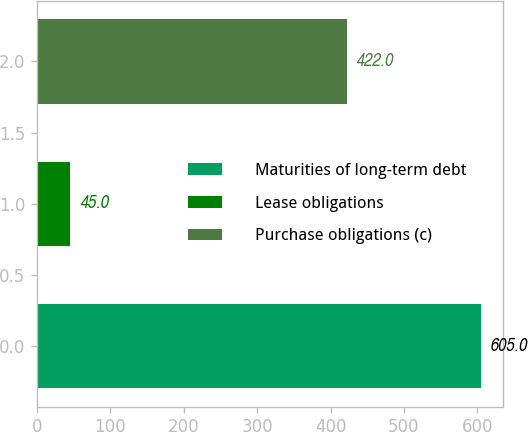Convert chart to OTSL. <chart><loc_0><loc_0><loc_500><loc_500><bar_chart><fcel>Maturities of long-term debt<fcel>Lease obligations<fcel>Purchase obligations (c)<nl><fcel>605<fcel>45<fcel>422<nl></chart> 